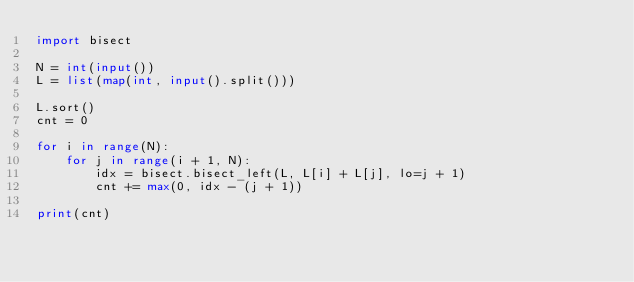<code> <loc_0><loc_0><loc_500><loc_500><_Python_>import bisect

N = int(input())
L = list(map(int, input().split()))

L.sort()
cnt = 0

for i in range(N):
    for j in range(i + 1, N):
        idx = bisect.bisect_left(L, L[i] + L[j], lo=j + 1)
        cnt += max(0, idx - (j + 1))
        
print(cnt)</code> 